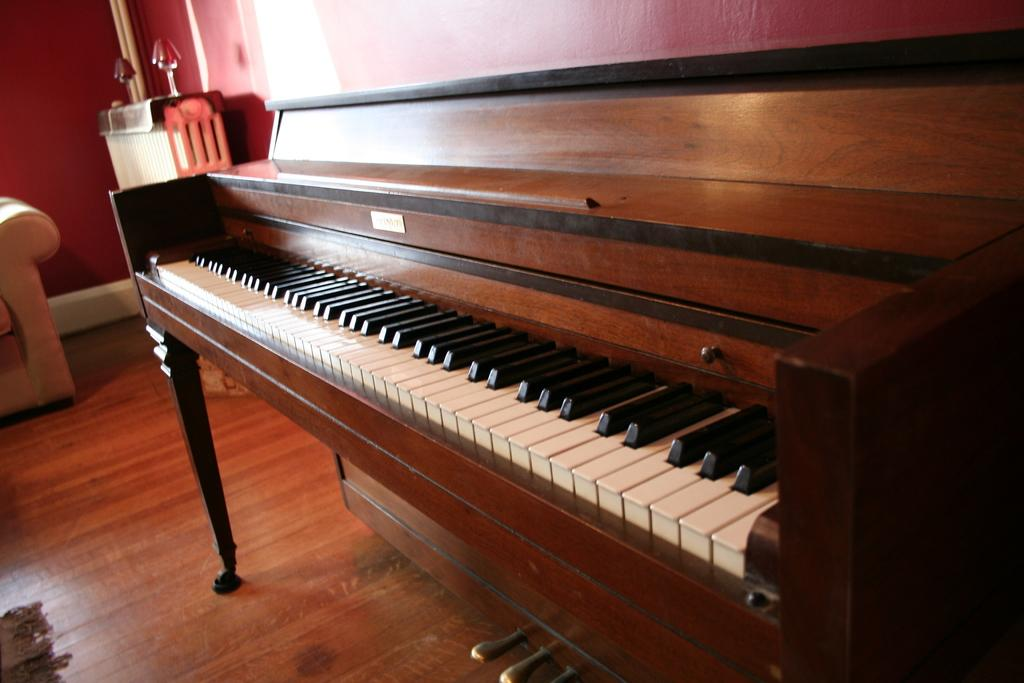What object in the image is used for creating music? There is a musical instrument in the image. What type of furniture is present in the image? There is a sofa in the image. What type of string is used to create heat in the image? There is no string or heat source present in the image. 